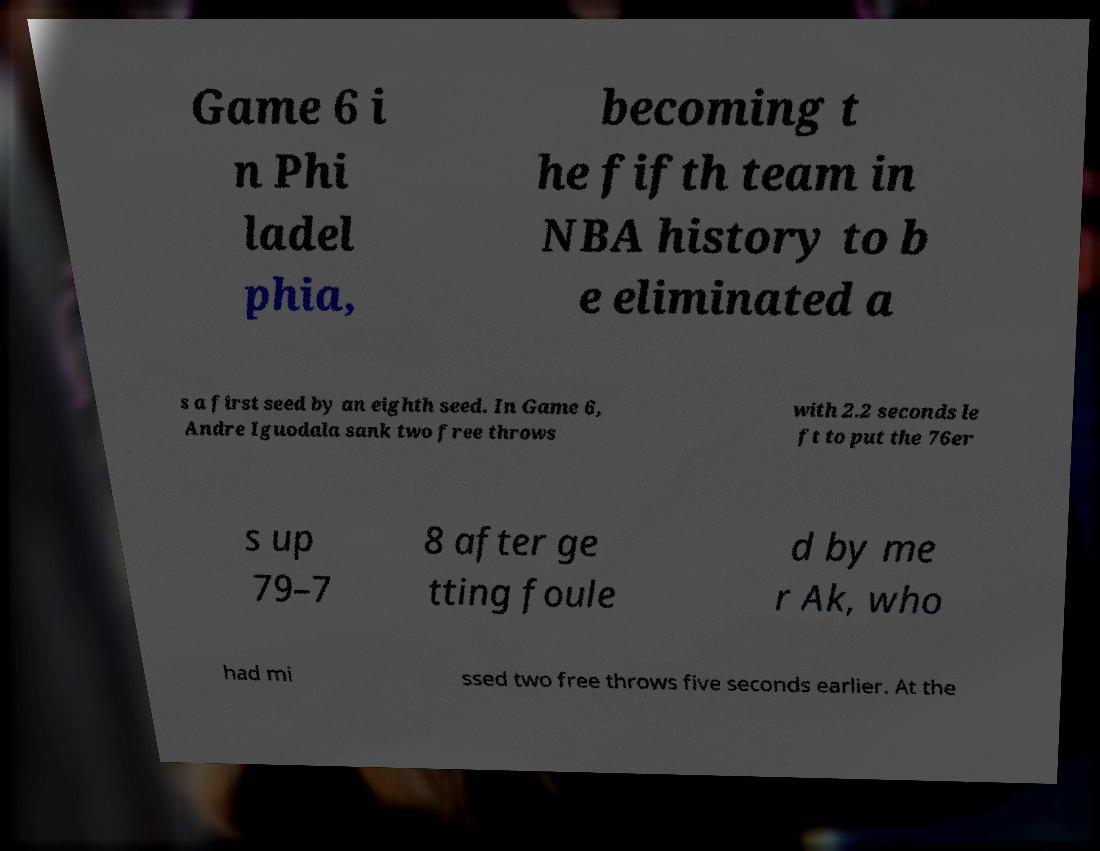For documentation purposes, I need the text within this image transcribed. Could you provide that? Game 6 i n Phi ladel phia, becoming t he fifth team in NBA history to b e eliminated a s a first seed by an eighth seed. In Game 6, Andre Iguodala sank two free throws with 2.2 seconds le ft to put the 76er s up 79–7 8 after ge tting foule d by me r Ak, who had mi ssed two free throws five seconds earlier. At the 